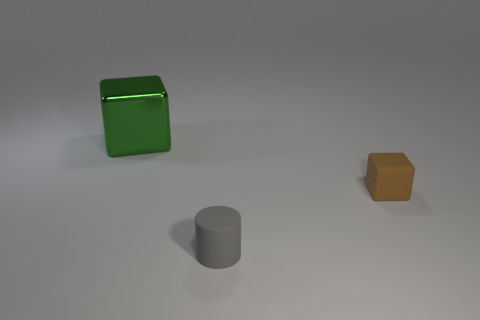Is there any other thing that has the same material as the large thing?
Your answer should be compact. No. How many things are either blocks that are in front of the large green metallic block or tiny cubes?
Your answer should be compact. 1. What number of objects are tiny cubes or cubes in front of the big green thing?
Your response must be concise. 1. What number of green metal cubes have the same size as the brown thing?
Provide a short and direct response. 0. Are there fewer rubber objects on the left side of the gray object than tiny cubes that are behind the small cube?
Offer a very short reply. No. What number of shiny objects are small cylinders or large blue cubes?
Your response must be concise. 0. The gray rubber thing has what shape?
Ensure brevity in your answer.  Cylinder. What is the material of the gray cylinder that is the same size as the brown matte thing?
Keep it short and to the point. Rubber. What number of big things are either green cylinders or brown blocks?
Provide a short and direct response. 0. Is there a gray shiny block?
Offer a very short reply. No. 